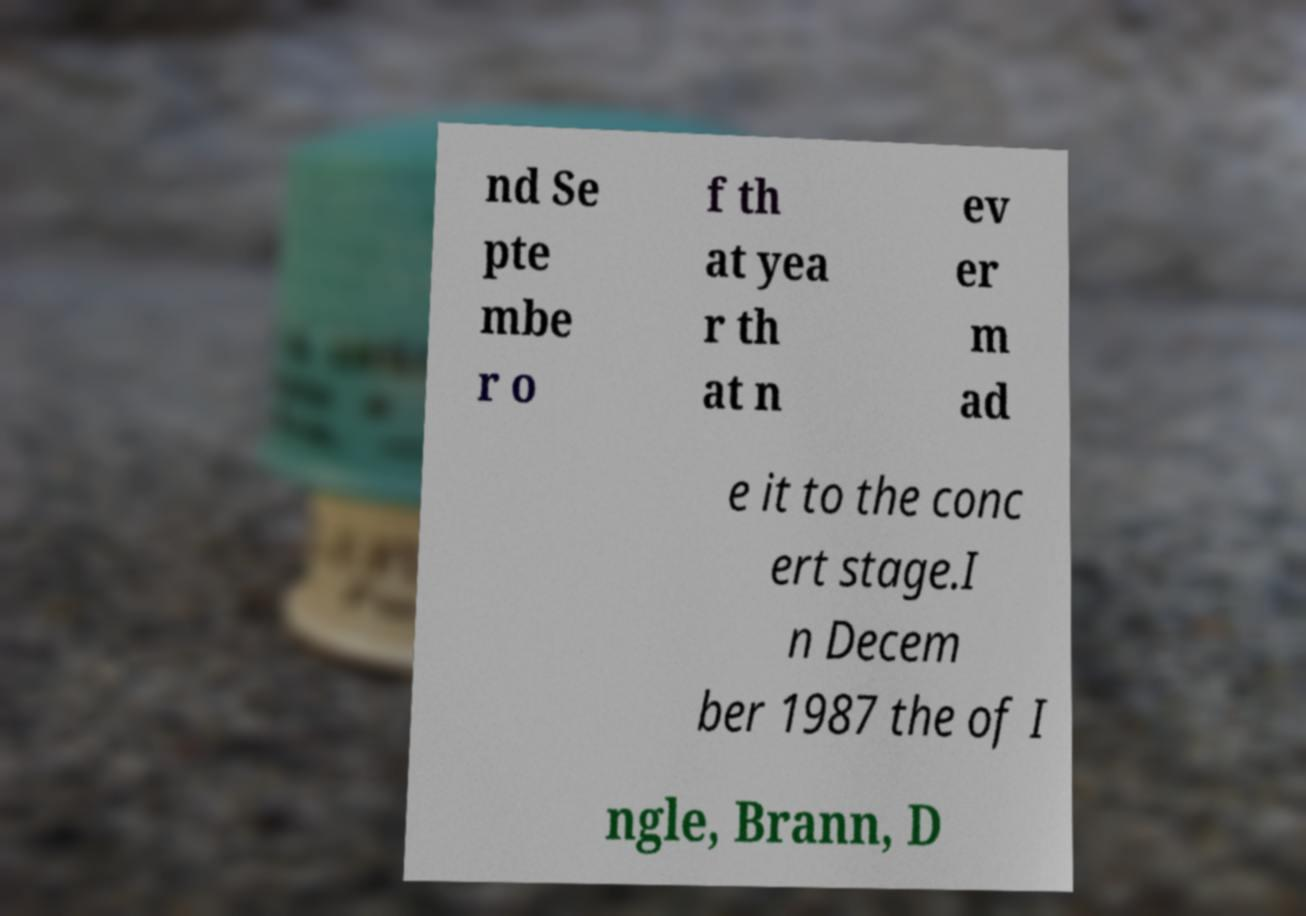Can you read and provide the text displayed in the image?This photo seems to have some interesting text. Can you extract and type it out for me? nd Se pte mbe r o f th at yea r th at n ev er m ad e it to the conc ert stage.I n Decem ber 1987 the of I ngle, Brann, D 